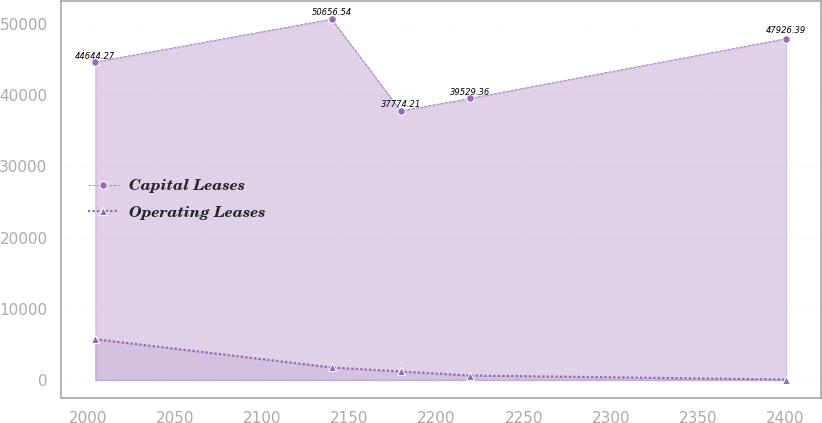Convert chart. <chart><loc_0><loc_0><loc_500><loc_500><line_chart><ecel><fcel>Capital Leases<fcel>Operating Leases<nl><fcel>2004.04<fcel>44644.3<fcel>5725.72<nl><fcel>2139.73<fcel>50656.5<fcel>1761.66<nl><fcel>2179.38<fcel>37774.2<fcel>1195.37<nl><fcel>2219.03<fcel>39529.4<fcel>629.08<nl><fcel>2400.56<fcel>47926.4<fcel>62.79<nl></chart> 